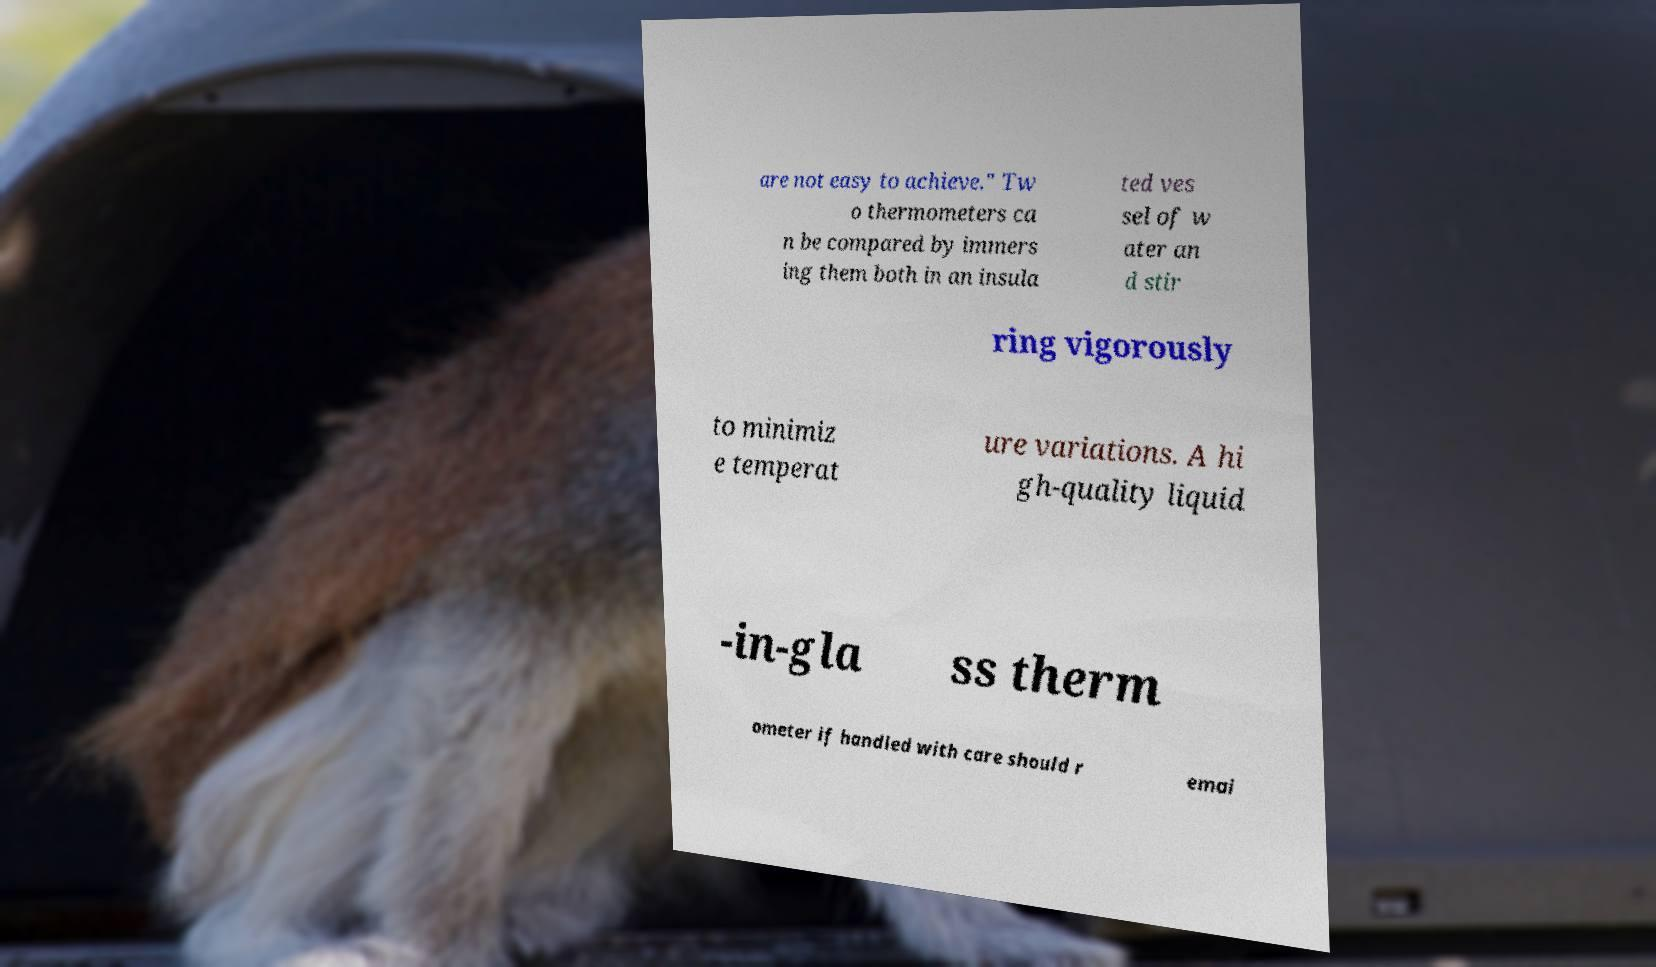Could you extract and type out the text from this image? are not easy to achieve." Tw o thermometers ca n be compared by immers ing them both in an insula ted ves sel of w ater an d stir ring vigorously to minimiz e temperat ure variations. A hi gh-quality liquid -in-gla ss therm ometer if handled with care should r emai 